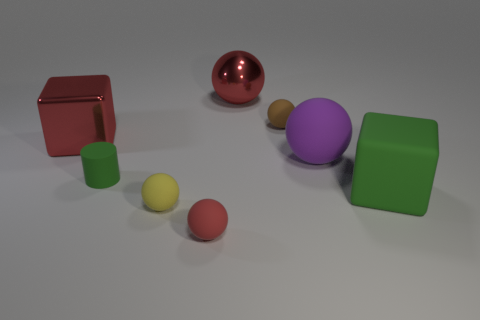There is a red shiny thing left of the red ball behind the purple rubber thing; what is its shape?
Give a very brief answer. Cube. There is a red block behind the purple matte thing; does it have the same size as the block that is to the right of the yellow sphere?
Make the answer very short. Yes. Is there a large yellow cylinder made of the same material as the green cylinder?
Ensure brevity in your answer.  No. There is a matte block that is the same color as the tiny cylinder; what size is it?
Offer a terse response. Large. There is a big matte object on the left side of the big object in front of the large purple ball; is there a small red object in front of it?
Your response must be concise. Yes. There is a purple rubber thing; are there any large blocks in front of it?
Your answer should be very brief. Yes. There is a large block to the left of the big rubber cube; how many small brown matte objects are in front of it?
Offer a terse response. 0. Is the size of the metal ball the same as the green object that is to the right of the matte cylinder?
Offer a terse response. Yes. Are there any matte blocks of the same color as the tiny cylinder?
Offer a very short reply. Yes. What is the size of the purple thing that is made of the same material as the yellow ball?
Your answer should be compact. Large. 